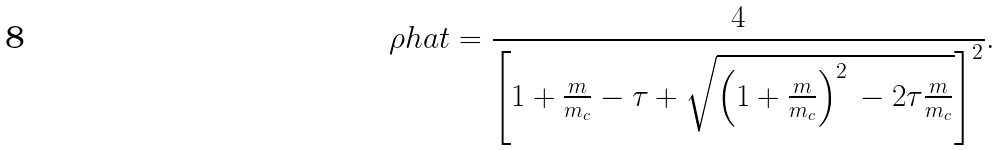Convert formula to latex. <formula><loc_0><loc_0><loc_500><loc_500>\rho h a t = \frac { 4 } { \left [ 1 + \frac { m } { m _ { c } } - \tau + \sqrt { \left ( 1 + \frac { m } { m _ { c } } \right ) ^ { 2 } \, - 2 \tau \frac { m } { m _ { c } } } \right ] ^ { 2 } } .</formula> 